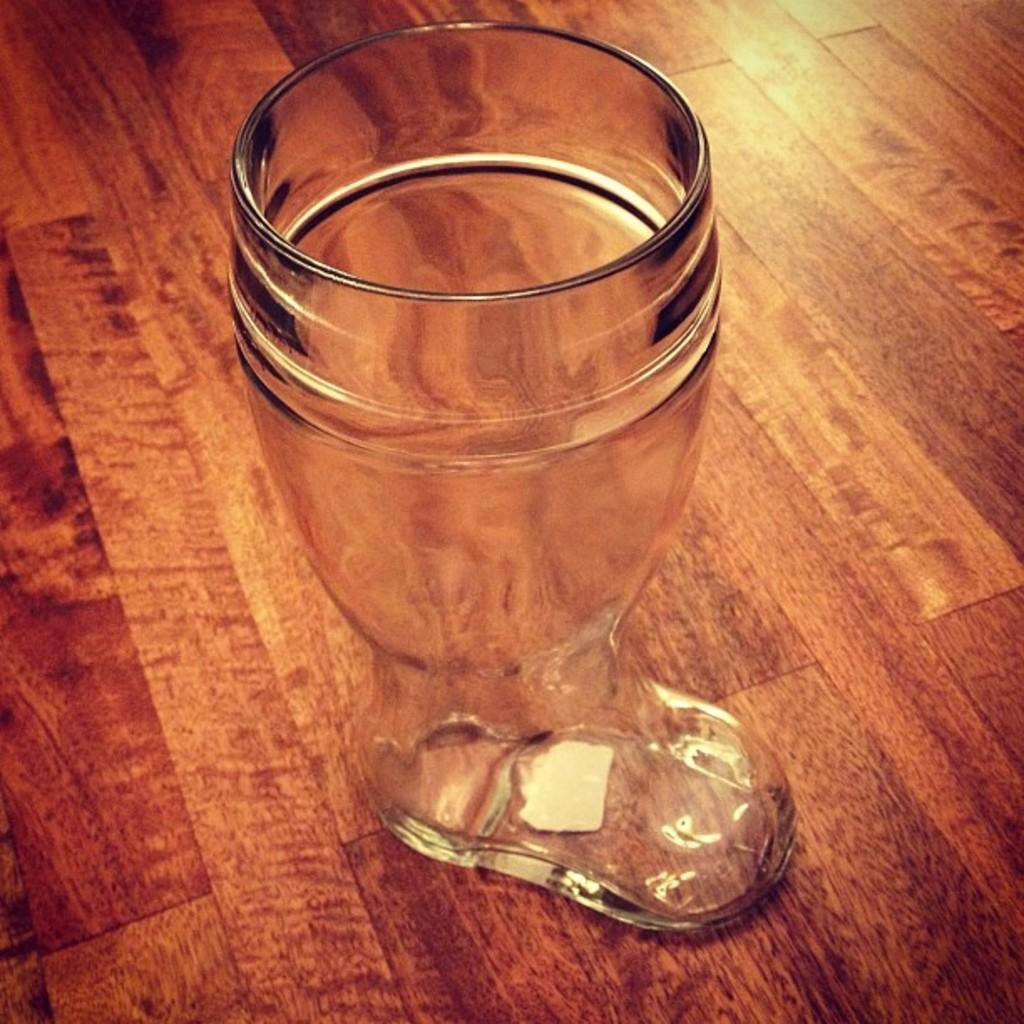What object is visible in the image? There is a glass in the image. What is the glass placed on? The glass is on a brown-colored surface. What type of wound can be seen on the knee of the person in the image? There is no person present in the image, and therefore no knee or wound can be observed. 